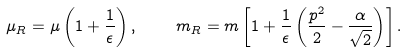<formula> <loc_0><loc_0><loc_500><loc_500>\mu _ { R } = \mu \left ( 1 + \frac { 1 } { \epsilon } \right ) , \quad \ m _ { R } = m \left [ 1 + \frac { 1 } { \epsilon } \left ( \frac { p ^ { 2 } } { 2 } - \frac { \alpha } { \sqrt { 2 } } \right ) \right ] .</formula> 